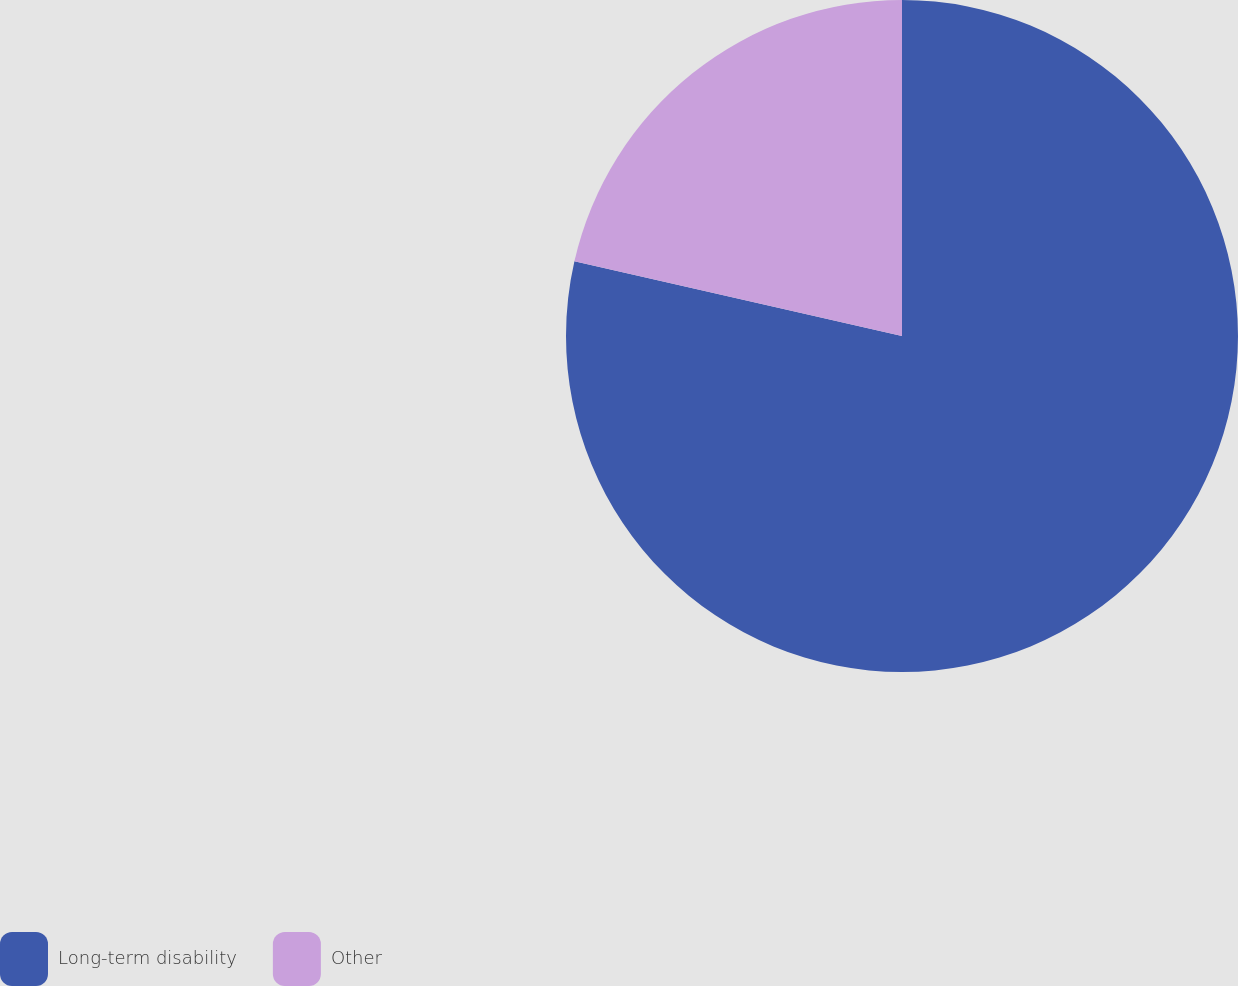<chart> <loc_0><loc_0><loc_500><loc_500><pie_chart><fcel>Long-term disability<fcel>Other<nl><fcel>78.57%<fcel>21.43%<nl></chart> 